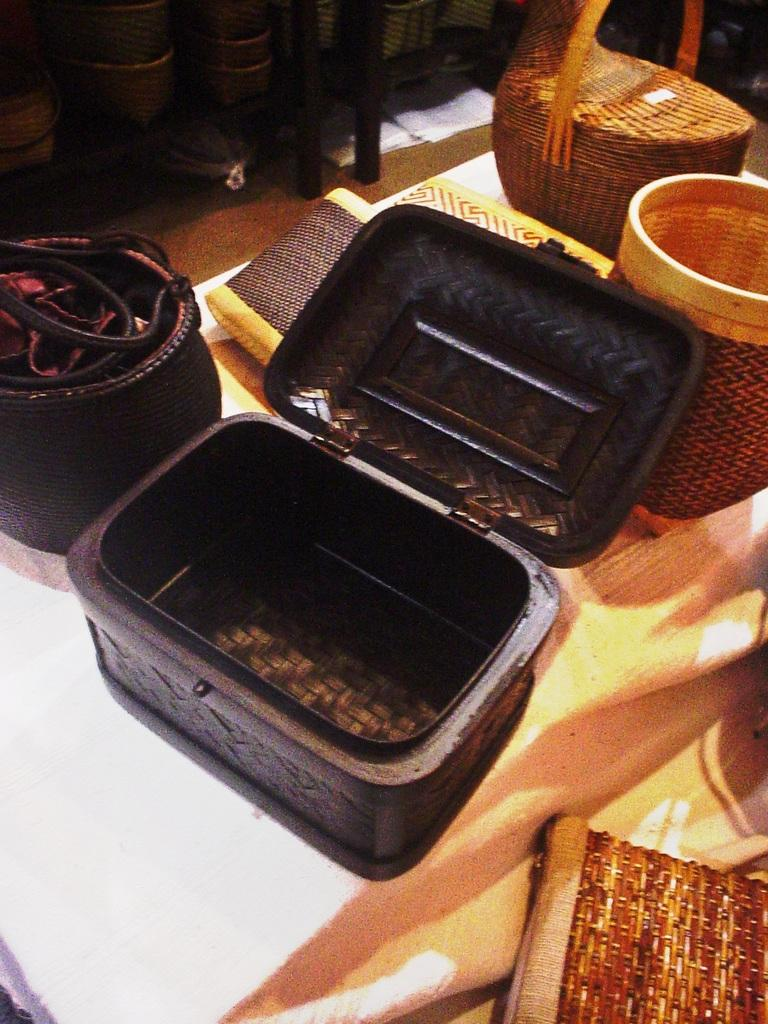What can be seen on the surface in the image? There are objects on the surface in the image. Can you describe the color of one object on the left side? One object at the left side is black in color. Where are other objects located in the image? There are other objects at the top of the image. How does the zebra find its way through the room in the image? There is no zebra present in the image, so it cannot be found or navigated through a room. 